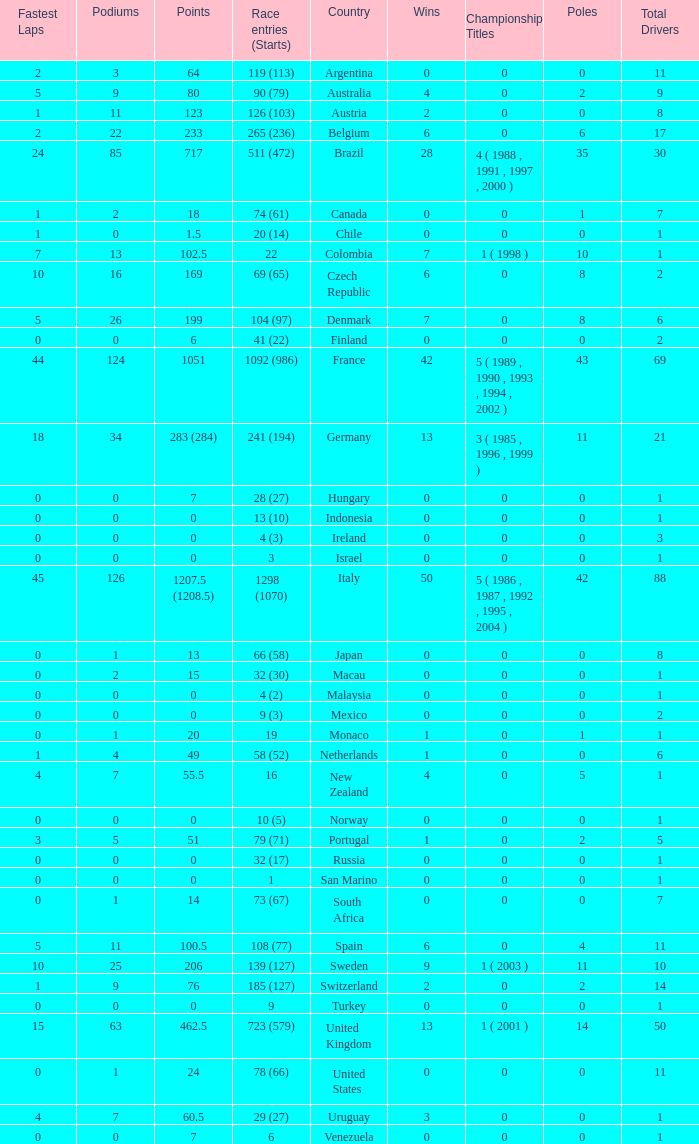How many titles for the nation with less than 3 fastest laps and 22 podiums? 0.0. 